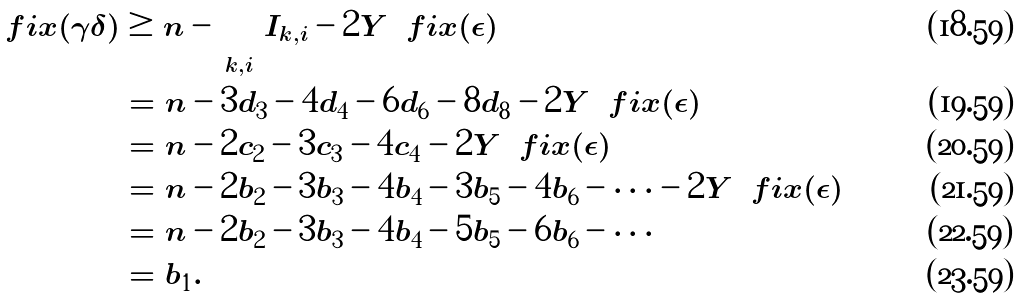Convert formula to latex. <formula><loc_0><loc_0><loc_500><loc_500>\ f i x ( \gamma \delta ) & \geq n - \sum _ { k , i } | I _ { k , i } | - 2 | Y \ \ f i x ( \epsilon ) | \\ & = n - 3 d _ { 3 } - 4 d _ { 4 } - 6 d _ { 6 } - 8 d _ { 8 } - 2 | Y \ \ f i x ( \epsilon ) | \\ & = n - 2 c _ { 2 } - 3 c _ { 3 } - 4 c _ { 4 } - 2 | Y \ \ f i x ( \epsilon ) | \\ & = n - 2 b _ { 2 } - 3 b _ { 3 } - 4 b _ { 4 } - 3 b _ { 5 } - 4 b _ { 6 } - \cdots - 2 | Y \ \ f i x ( \epsilon ) | \\ & = n - 2 b _ { 2 } - 3 b _ { 3 } - 4 b _ { 4 } - 5 b _ { 5 } - 6 b _ { 6 } - \cdots \\ & = b _ { 1 } .</formula> 